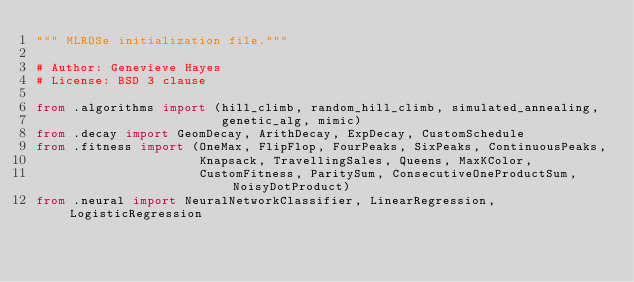Convert code to text. <code><loc_0><loc_0><loc_500><loc_500><_Python_>""" MLROSe initialization file."""

# Author: Genevieve Hayes
# License: BSD 3 clause

from .algorithms import (hill_climb, random_hill_climb, simulated_annealing,
                         genetic_alg, mimic)
from .decay import GeomDecay, ArithDecay, ExpDecay, CustomSchedule
from .fitness import (OneMax, FlipFlop, FourPeaks, SixPeaks, ContinuousPeaks,
                      Knapsack, TravellingSales, Queens, MaxKColor, 
                      CustomFitness, ParitySum, ConsecutiveOneProductSum, NoisyDotProduct)
from .neural import NeuralNetworkClassifier, LinearRegression, LogisticRegression</code> 